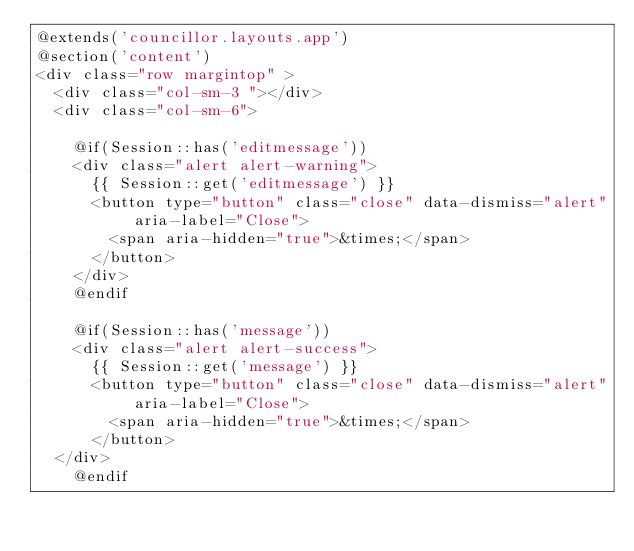<code> <loc_0><loc_0><loc_500><loc_500><_PHP_>@extends('councillor.layouts.app')
@section('content')  
<div class="row margintop" >
  <div class="col-sm-3 "></div>
  <div class="col-sm-6">
    
    @if(Session::has('editmessage'))
    <div class="alert alert-warning">
      {{ Session::get('editmessage') }} 
      <button type="button" class="close" data-dismiss="alert" aria-label="Close">
        <span aria-hidden="true">&times;</span>
      </button>
    </div>
    @endif

    @if(Session::has('message'))
    <div class="alert alert-success">
      {{ Session::get('message') }}
      <button type="button" class="close" data-dismiss="alert" aria-label="Close">
        <span aria-hidden="true">&times;</span>
      </button>
  </div>
    @endif</code> 